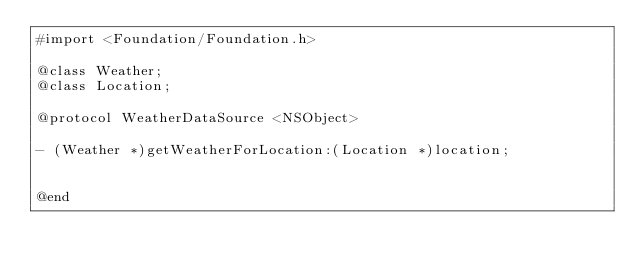<code> <loc_0><loc_0><loc_500><loc_500><_C_>#import <Foundation/Foundation.h>

@class Weather;
@class Location;

@protocol WeatherDataSource <NSObject>

- (Weather *)getWeatherForLocation:(Location *)location;


@end</code> 